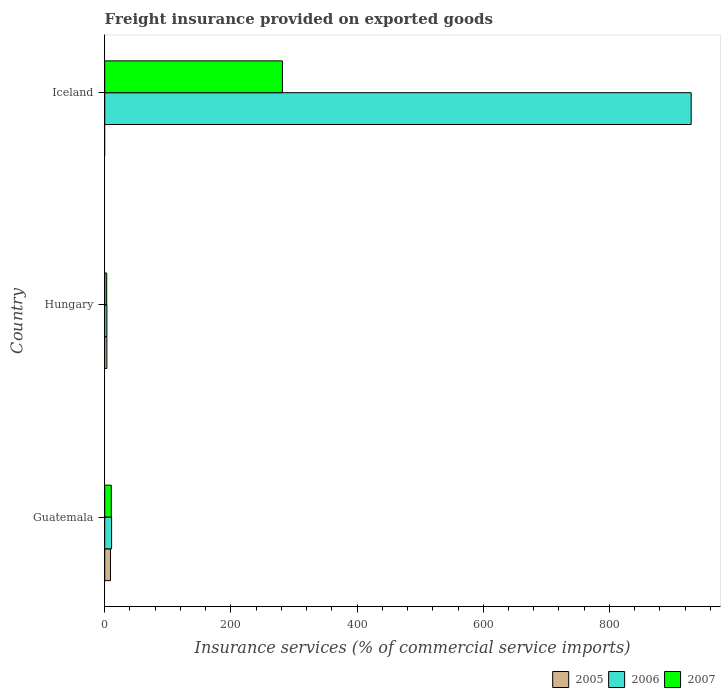How many different coloured bars are there?
Your answer should be compact. 3. Are the number of bars on each tick of the Y-axis equal?
Offer a terse response. No. How many bars are there on the 1st tick from the top?
Keep it short and to the point. 2. What is the label of the 2nd group of bars from the top?
Give a very brief answer. Hungary. What is the freight insurance provided on exported goods in 2005 in Guatemala?
Your answer should be very brief. 9.14. Across all countries, what is the maximum freight insurance provided on exported goods in 2005?
Offer a very short reply. 9.14. Across all countries, what is the minimum freight insurance provided on exported goods in 2007?
Give a very brief answer. 3.16. In which country was the freight insurance provided on exported goods in 2007 maximum?
Provide a succinct answer. Iceland. What is the total freight insurance provided on exported goods in 2007 in the graph?
Offer a terse response. 295.25. What is the difference between the freight insurance provided on exported goods in 2007 in Hungary and that in Iceland?
Your answer should be very brief. -278.52. What is the difference between the freight insurance provided on exported goods in 2005 in Iceland and the freight insurance provided on exported goods in 2006 in Hungary?
Keep it short and to the point. -3.46. What is the average freight insurance provided on exported goods in 2006 per country?
Your response must be concise. 314.66. What is the difference between the freight insurance provided on exported goods in 2007 and freight insurance provided on exported goods in 2006 in Hungary?
Offer a very short reply. -0.3. What is the ratio of the freight insurance provided on exported goods in 2006 in Guatemala to that in Hungary?
Ensure brevity in your answer.  3.16. Is the freight insurance provided on exported goods in 2007 in Guatemala less than that in Hungary?
Make the answer very short. No. What is the difference between the highest and the second highest freight insurance provided on exported goods in 2007?
Your answer should be compact. 271.27. What is the difference between the highest and the lowest freight insurance provided on exported goods in 2006?
Provide a short and direct response. 926.14. Is it the case that in every country, the sum of the freight insurance provided on exported goods in 2005 and freight insurance provided on exported goods in 2006 is greater than the freight insurance provided on exported goods in 2007?
Your answer should be very brief. Yes. Are all the bars in the graph horizontal?
Offer a very short reply. Yes. How many countries are there in the graph?
Give a very brief answer. 3. What is the difference between two consecutive major ticks on the X-axis?
Your answer should be very brief. 200. Does the graph contain any zero values?
Your answer should be compact. Yes. Does the graph contain grids?
Your answer should be very brief. No. Where does the legend appear in the graph?
Make the answer very short. Bottom right. How are the legend labels stacked?
Give a very brief answer. Horizontal. What is the title of the graph?
Your answer should be compact. Freight insurance provided on exported goods. What is the label or title of the X-axis?
Your response must be concise. Insurance services (% of commercial service imports). What is the label or title of the Y-axis?
Your response must be concise. Country. What is the Insurance services (% of commercial service imports) in 2005 in Guatemala?
Your answer should be very brief. 9.14. What is the Insurance services (% of commercial service imports) of 2006 in Guatemala?
Keep it short and to the point. 10.92. What is the Insurance services (% of commercial service imports) in 2007 in Guatemala?
Make the answer very short. 10.41. What is the Insurance services (% of commercial service imports) in 2005 in Hungary?
Provide a succinct answer. 3.41. What is the Insurance services (% of commercial service imports) of 2006 in Hungary?
Keep it short and to the point. 3.46. What is the Insurance services (% of commercial service imports) in 2007 in Hungary?
Offer a terse response. 3.16. What is the Insurance services (% of commercial service imports) of 2005 in Iceland?
Your answer should be compact. 0. What is the Insurance services (% of commercial service imports) in 2006 in Iceland?
Give a very brief answer. 929.6. What is the Insurance services (% of commercial service imports) of 2007 in Iceland?
Your answer should be compact. 281.68. Across all countries, what is the maximum Insurance services (% of commercial service imports) of 2005?
Give a very brief answer. 9.14. Across all countries, what is the maximum Insurance services (% of commercial service imports) of 2006?
Keep it short and to the point. 929.6. Across all countries, what is the maximum Insurance services (% of commercial service imports) of 2007?
Keep it short and to the point. 281.68. Across all countries, what is the minimum Insurance services (% of commercial service imports) in 2006?
Keep it short and to the point. 3.46. Across all countries, what is the minimum Insurance services (% of commercial service imports) of 2007?
Offer a terse response. 3.16. What is the total Insurance services (% of commercial service imports) of 2005 in the graph?
Your answer should be compact. 12.55. What is the total Insurance services (% of commercial service imports) in 2006 in the graph?
Ensure brevity in your answer.  943.98. What is the total Insurance services (% of commercial service imports) in 2007 in the graph?
Ensure brevity in your answer.  295.25. What is the difference between the Insurance services (% of commercial service imports) of 2005 in Guatemala and that in Hungary?
Provide a succinct answer. 5.73. What is the difference between the Insurance services (% of commercial service imports) of 2006 in Guatemala and that in Hungary?
Make the answer very short. 7.46. What is the difference between the Insurance services (% of commercial service imports) in 2007 in Guatemala and that in Hungary?
Keep it short and to the point. 7.25. What is the difference between the Insurance services (% of commercial service imports) of 2006 in Guatemala and that in Iceland?
Your answer should be very brief. -918.68. What is the difference between the Insurance services (% of commercial service imports) of 2007 in Guatemala and that in Iceland?
Your answer should be very brief. -271.27. What is the difference between the Insurance services (% of commercial service imports) in 2006 in Hungary and that in Iceland?
Your response must be concise. -926.14. What is the difference between the Insurance services (% of commercial service imports) of 2007 in Hungary and that in Iceland?
Offer a terse response. -278.52. What is the difference between the Insurance services (% of commercial service imports) in 2005 in Guatemala and the Insurance services (% of commercial service imports) in 2006 in Hungary?
Ensure brevity in your answer.  5.68. What is the difference between the Insurance services (% of commercial service imports) in 2005 in Guatemala and the Insurance services (% of commercial service imports) in 2007 in Hungary?
Give a very brief answer. 5.98. What is the difference between the Insurance services (% of commercial service imports) in 2006 in Guatemala and the Insurance services (% of commercial service imports) in 2007 in Hungary?
Keep it short and to the point. 7.76. What is the difference between the Insurance services (% of commercial service imports) in 2005 in Guatemala and the Insurance services (% of commercial service imports) in 2006 in Iceland?
Ensure brevity in your answer.  -920.46. What is the difference between the Insurance services (% of commercial service imports) of 2005 in Guatemala and the Insurance services (% of commercial service imports) of 2007 in Iceland?
Make the answer very short. -272.54. What is the difference between the Insurance services (% of commercial service imports) in 2006 in Guatemala and the Insurance services (% of commercial service imports) in 2007 in Iceland?
Provide a short and direct response. -270.76. What is the difference between the Insurance services (% of commercial service imports) of 2005 in Hungary and the Insurance services (% of commercial service imports) of 2006 in Iceland?
Make the answer very short. -926.18. What is the difference between the Insurance services (% of commercial service imports) in 2005 in Hungary and the Insurance services (% of commercial service imports) in 2007 in Iceland?
Give a very brief answer. -278.26. What is the difference between the Insurance services (% of commercial service imports) of 2006 in Hungary and the Insurance services (% of commercial service imports) of 2007 in Iceland?
Your answer should be compact. -278.22. What is the average Insurance services (% of commercial service imports) of 2005 per country?
Ensure brevity in your answer.  4.18. What is the average Insurance services (% of commercial service imports) in 2006 per country?
Offer a terse response. 314.66. What is the average Insurance services (% of commercial service imports) in 2007 per country?
Offer a very short reply. 98.42. What is the difference between the Insurance services (% of commercial service imports) in 2005 and Insurance services (% of commercial service imports) in 2006 in Guatemala?
Give a very brief answer. -1.78. What is the difference between the Insurance services (% of commercial service imports) of 2005 and Insurance services (% of commercial service imports) of 2007 in Guatemala?
Offer a very short reply. -1.27. What is the difference between the Insurance services (% of commercial service imports) in 2006 and Insurance services (% of commercial service imports) in 2007 in Guatemala?
Provide a short and direct response. 0.51. What is the difference between the Insurance services (% of commercial service imports) of 2005 and Insurance services (% of commercial service imports) of 2006 in Hungary?
Your answer should be very brief. -0.05. What is the difference between the Insurance services (% of commercial service imports) in 2005 and Insurance services (% of commercial service imports) in 2007 in Hungary?
Offer a terse response. 0.26. What is the difference between the Insurance services (% of commercial service imports) of 2006 and Insurance services (% of commercial service imports) of 2007 in Hungary?
Keep it short and to the point. 0.3. What is the difference between the Insurance services (% of commercial service imports) of 2006 and Insurance services (% of commercial service imports) of 2007 in Iceland?
Keep it short and to the point. 647.92. What is the ratio of the Insurance services (% of commercial service imports) of 2005 in Guatemala to that in Hungary?
Your answer should be very brief. 2.68. What is the ratio of the Insurance services (% of commercial service imports) in 2006 in Guatemala to that in Hungary?
Your response must be concise. 3.16. What is the ratio of the Insurance services (% of commercial service imports) of 2007 in Guatemala to that in Hungary?
Ensure brevity in your answer.  3.3. What is the ratio of the Insurance services (% of commercial service imports) in 2006 in Guatemala to that in Iceland?
Your answer should be very brief. 0.01. What is the ratio of the Insurance services (% of commercial service imports) in 2007 in Guatemala to that in Iceland?
Provide a succinct answer. 0.04. What is the ratio of the Insurance services (% of commercial service imports) of 2006 in Hungary to that in Iceland?
Ensure brevity in your answer.  0. What is the ratio of the Insurance services (% of commercial service imports) in 2007 in Hungary to that in Iceland?
Keep it short and to the point. 0.01. What is the difference between the highest and the second highest Insurance services (% of commercial service imports) in 2006?
Your response must be concise. 918.68. What is the difference between the highest and the second highest Insurance services (% of commercial service imports) of 2007?
Provide a short and direct response. 271.27. What is the difference between the highest and the lowest Insurance services (% of commercial service imports) in 2005?
Your answer should be very brief. 9.14. What is the difference between the highest and the lowest Insurance services (% of commercial service imports) of 2006?
Offer a very short reply. 926.14. What is the difference between the highest and the lowest Insurance services (% of commercial service imports) of 2007?
Provide a short and direct response. 278.52. 